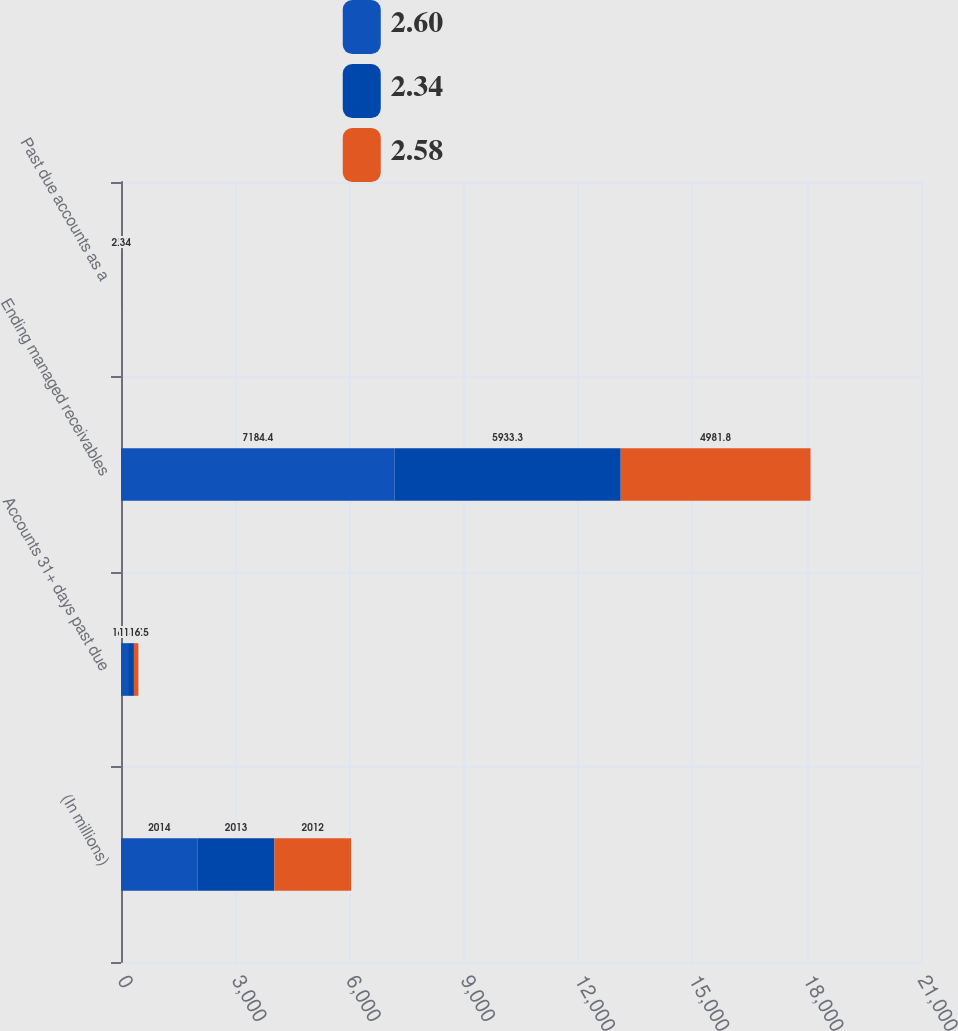<chart> <loc_0><loc_0><loc_500><loc_500><stacked_bar_chart><ecel><fcel>(In millions)<fcel>Accounts 31+ days past due<fcel>Ending managed receivables<fcel>Past due accounts as a<nl><fcel>2.6<fcel>2014<fcel>185.2<fcel>7184.4<fcel>2.58<nl><fcel>2.34<fcel>2013<fcel>154.2<fcel>5933.3<fcel>2.6<nl><fcel>2.58<fcel>2012<fcel>116.5<fcel>4981.8<fcel>2.34<nl></chart> 